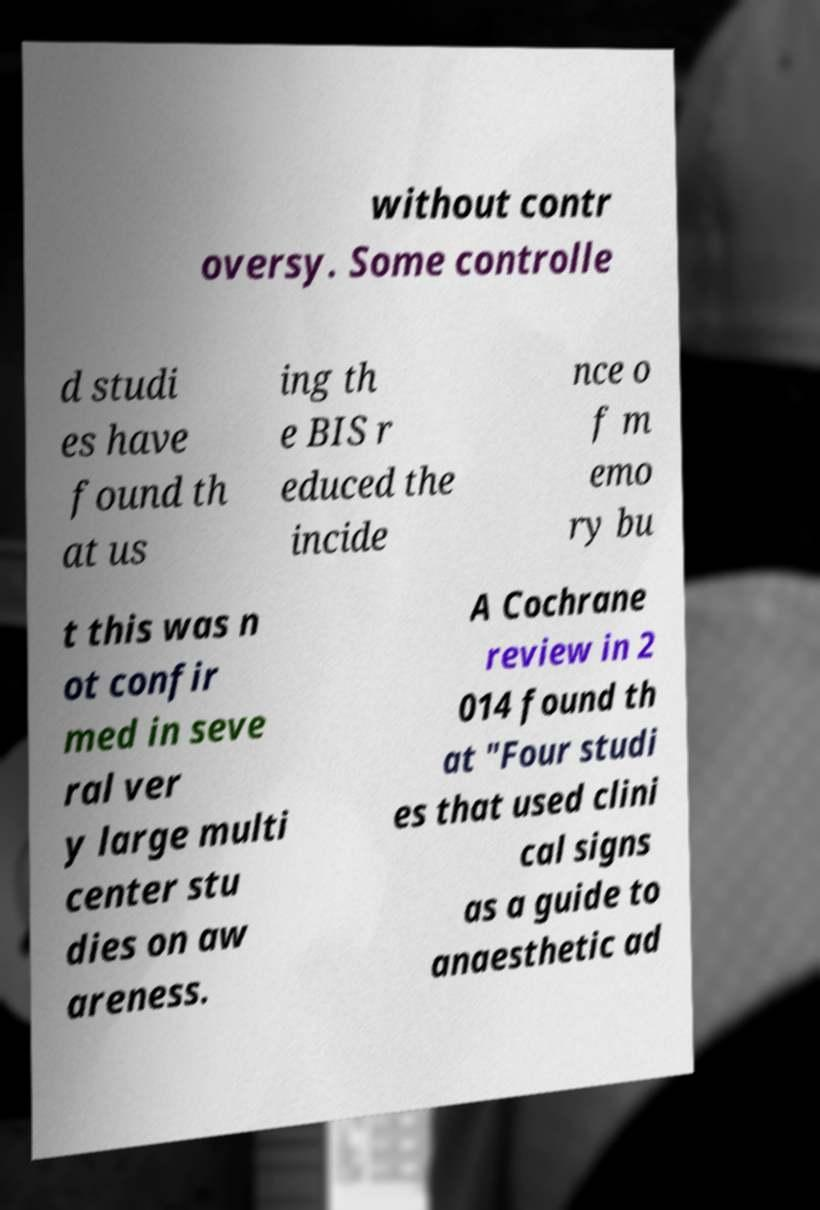Please read and relay the text visible in this image. What does it say? without contr oversy. Some controlle d studi es have found th at us ing th e BIS r educed the incide nce o f m emo ry bu t this was n ot confir med in seve ral ver y large multi center stu dies on aw areness. A Cochrane review in 2 014 found th at "Four studi es that used clini cal signs as a guide to anaesthetic ad 